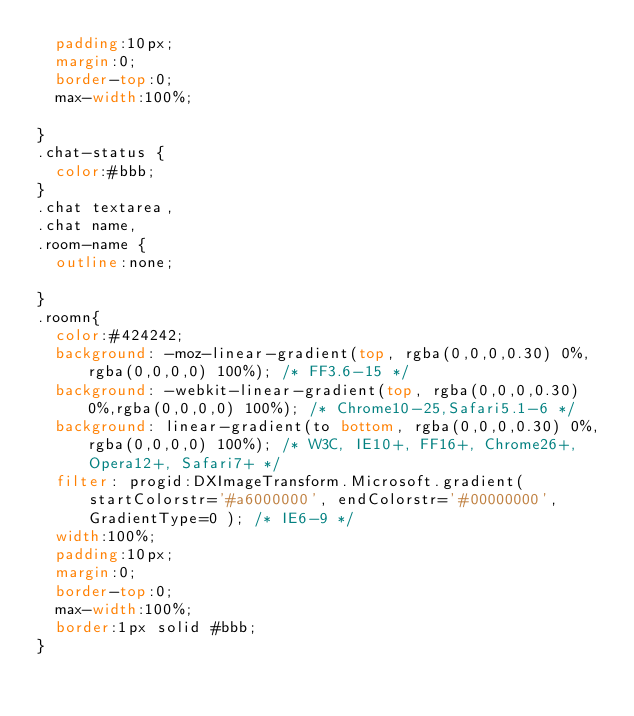Convert code to text. <code><loc_0><loc_0><loc_500><loc_500><_CSS_>	padding:10px;
	margin:0;
	border-top:0;
	max-width:100%;

}
.chat-status {
	color:#bbb;
}
.chat textarea,
.chat name,
.room-name {
	outline:none;

}
.roomn{
	color:#424242;
	background: -moz-linear-gradient(top, rgba(0,0,0,0.30) 0%, rgba(0,0,0,0) 100%); /* FF3.6-15 */
	background: -webkit-linear-gradient(top, rgba(0,0,0,0.30) 0%,rgba(0,0,0,0) 100%); /* Chrome10-25,Safari5.1-6 */
	background: linear-gradient(to bottom, rgba(0,0,0,0.30) 0%,rgba(0,0,0,0) 100%); /* W3C, IE10+, FF16+, Chrome26+, Opera12+, Safari7+ */
	filter: progid:DXImageTransform.Microsoft.gradient( startColorstr='#a6000000', endColorstr='#00000000',GradientType=0 ); /* IE6-9 */
	width:100%;
	padding:10px;
	margin:0;
	border-top:0;
	max-width:100%;
	border:1px solid #bbb;
}
</code> 